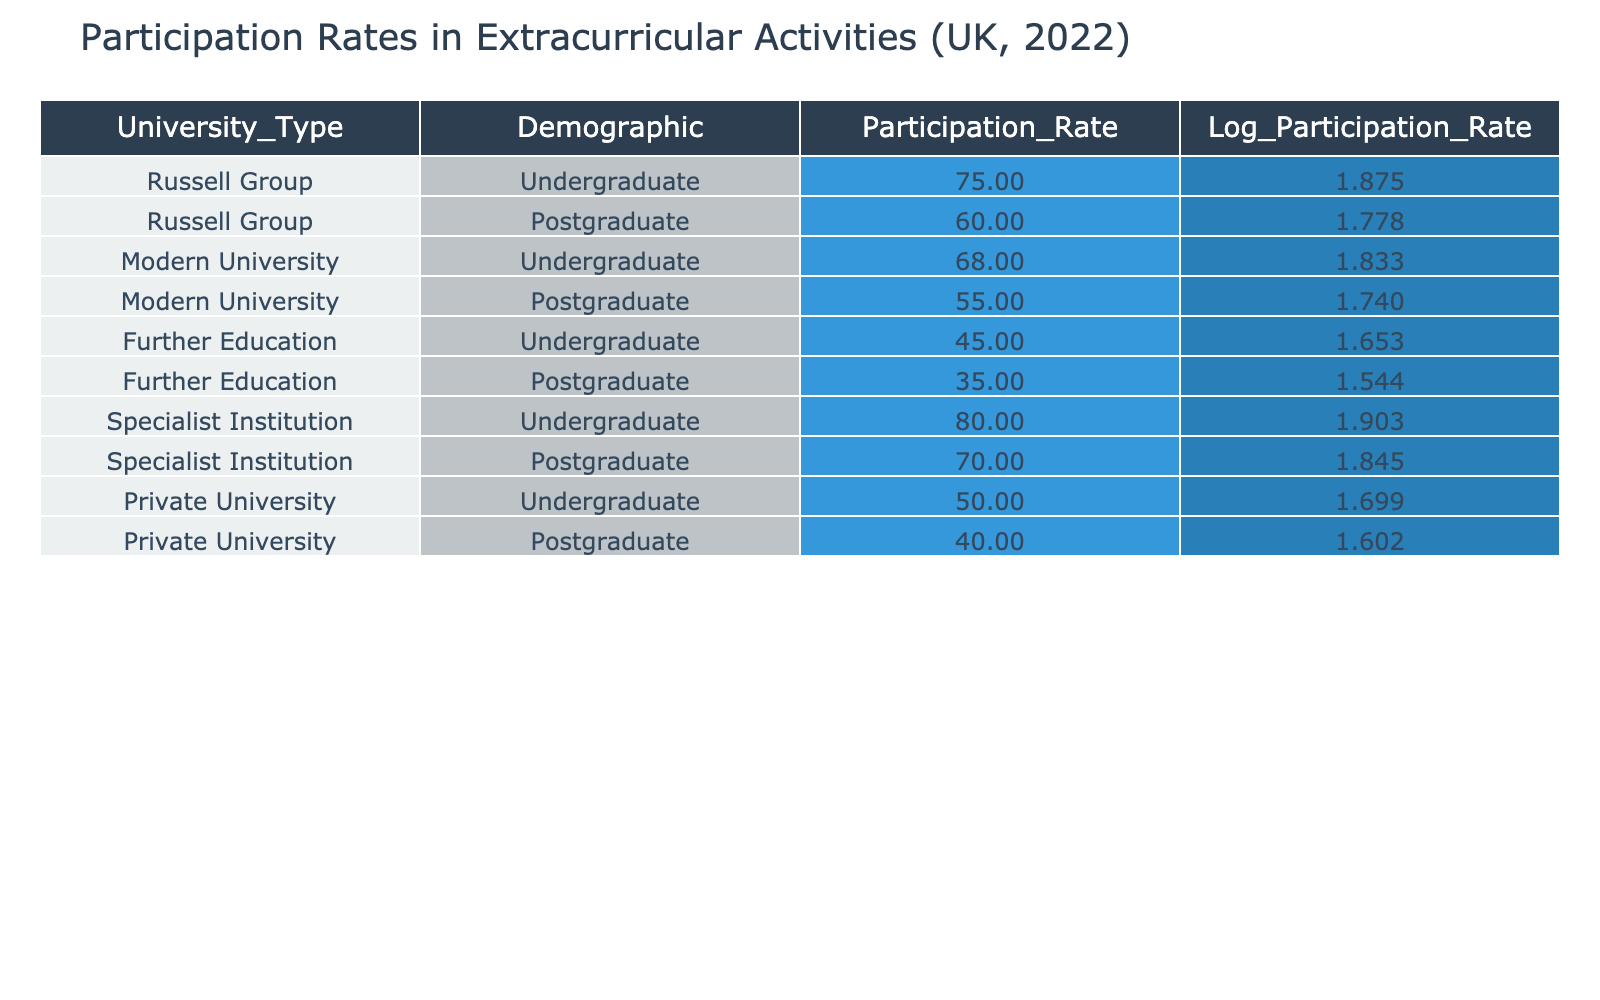What is the participation rate for undergraduates at Specialist Institutions? From the table, the participation rate for undergraduates at Specialist Institutions is directly listed under the respective column. It shows a participation rate of 80.
Answer: 80 What is the difference in participation rates between undergraduate and postgraduate students in Modern Universities? By looking at the table, the undergraduate participation rate in Modern Universities is 68 and the postgraduate rate is 55. The difference is calculated as 68 - 55 = 13.
Answer: 13 Is the participation rate of postgraduate students at Private Universities higher than that at Further Education institutions? The participation rate for postgraduate students at Private Universities is 40, while at Further Education it is 35. Since 40 is greater than 35, the statement is true.
Answer: Yes What is the average participation rate for undergraduates across all university types? To find the average for undergraduates, sum the rates: 75 + 68 + 45 + 80 + 50 = 318. There are 5 entries for undergraduates, so the average is 318 / 5 = 63.6.
Answer: 63.6 Which university type has the highest participation rate for postgraduate students? Looking at the postgraduate rates in the table, we see 60 for Russell Group, 55 for Modern University, 35 for Further Education, 70 for Specialist Institution, and 40 for Private University. The highest rate is 70 for Specialist Institutions.
Answer: Specialist Institution What is the total participation rate for all undergraduate students across all university types? Summing the participation rates for undergraduates: 75 + 68 + 45 + 80 + 50 = 318, which gives the total participation rate for undergraduate students across all types.
Answer: 318 Is the participation rate for postgraduate students at Russell Group higher than that at Specialist Institutions? The participation rate for Russell Group postgraduate students is 60, while for Specialist Institutions, it is 70. Since 60 is less than 70, the statement is false.
Answer: No What percentage of participants are undergraduates at Further Education when considering both undergraduate and postgraduate rates? First, we find the total for Further Education: 45 for undergraduates and 35 for postgraduates, giving a total of 80. The percentage of undergraduates is (45 / 80) * 100 = 56.25%.
Answer: 56.25 